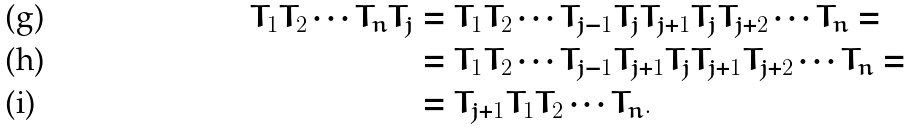Convert formula to latex. <formula><loc_0><loc_0><loc_500><loc_500>T _ { 1 } T _ { 2 } \cdots T _ { n } T _ { j } & = T _ { 1 } T _ { 2 } \cdots T _ { j - 1 } T _ { j } T _ { j + 1 } T _ { j } T _ { j + 2 } \cdots T _ { n } = \\ & = T _ { 1 } T _ { 2 } \cdots T _ { j - 1 } T _ { j + 1 } T _ { j } T _ { j + 1 } T _ { j + 2 } \cdots T _ { n } = \\ & = T _ { j + 1 } T _ { 1 } T _ { 2 } \cdots T _ { n } .</formula> 